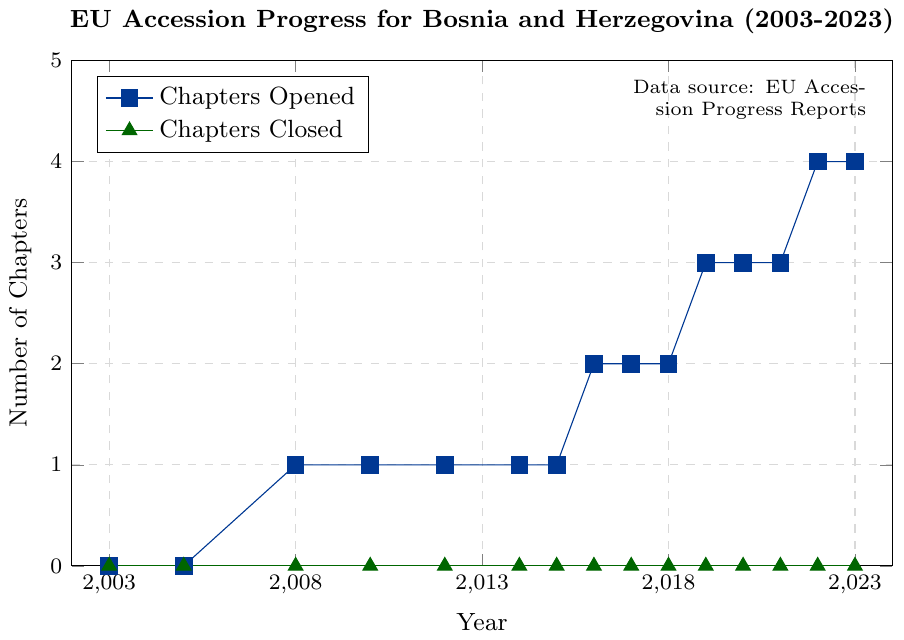Do the number of chapters opened and closed ever intersect? To check if the lines intersect, observe the values of 'Chapters Opened' and 'Chapters Closed' for each year. You will see that the number of chapters closed remains zero throughout the period, while the number of chapters opened increases. Hence, they never intersect.
Answer: No In which year did Bosnia and Herzegovina first open a chapter? Look at the 'Chapters Opened' line and identify the first year where it rises from zero. This occurs in 2008.
Answer: 2008 How many chapters were opened by 2023? The 'Chapters Opened' line ends at 4 in the year 2023. This indicates that four chapters were opened by that year.
Answer: 4 How many years did Bosnia and Herzegovina open at least one chapter? Count the distinct years where the 'Chapters Opened' value increases from the previous data point: 2008, 2016, 2019, and 2022. This sums up to four years.
Answer: 4 Describe the trend of the 'Chapters Closed' data over the years. Observe the 'Chapters Closed' line, which is entirely flat at zero from 2003 to 2023. This indicates no chapters were closed in any year.
Answer: Flat, no chapters closed How many chapters were opened between 2016 and 2019? Determine the number of chapters opened in 2019 (3) and subtract the number opened in 2016 (2). Thus, 3 - 2 = 1 chapter was opened between these years.
Answer: 1 What is the visual difference between the two lines in the plot? The 'Chapters Opened' line is represented with square markers and exhibits an upward trend, while the 'Chapters Closed' line uses triangle markers and remains flat at zero.
Answer: Square markers and upward trend vs. triangle markers and flat line By how much did the number of 'Chapters Opened' increase from 2015 to 2016? Check the values of 'Chapters Opened' for 2015 (1) and 2016 (2). The increase is 2 - 1 = 1 chapter.
Answer: 1 Between which consecutive years did the largest increase in 'Chapters Opened' occur? Compare the differences between consecutive years for 'Chapters Opened': 2008 (1), 2016 (2), 2019 (3), and 2022 (4). The largest increase occurs between 2015 and 2016 with a rise from 1 to 2 chapters.
Answer: 2015 to 2016 How many chapters were opened by 2018 without subtracting from previous years? Identify the value of 'Chapters Opened' in 2018, which is 2. This means two chapters were opened by 2018.
Answer: 2 